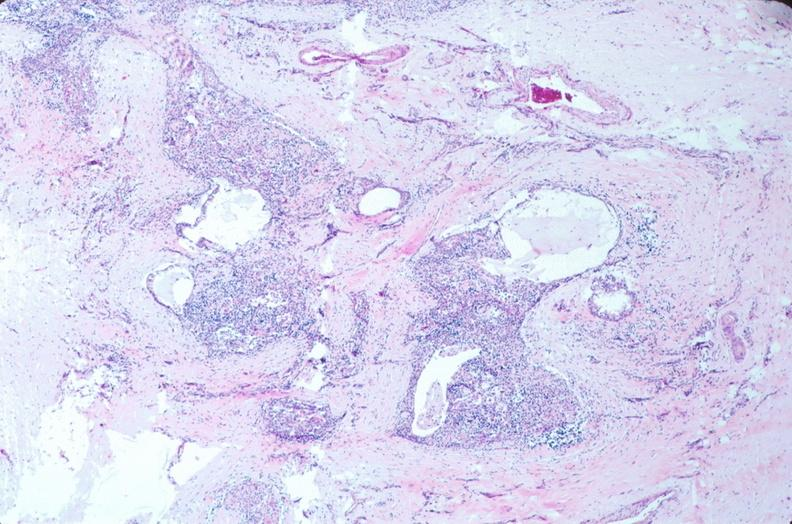s embryo-fetus present?
Answer the question using a single word or phrase. Yes 